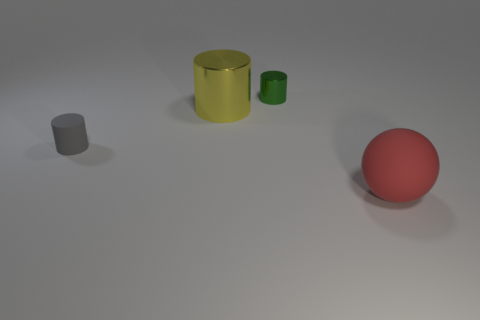What is the shape of the object that is behind the small rubber object and in front of the green cylinder?
Make the answer very short. Cylinder. The other small thing that is the same shape as the small gray thing is what color?
Provide a short and direct response. Green. Is there any other thing of the same color as the small metal thing?
Your answer should be compact. No. What is the shape of the rubber thing that is on the right side of the matte object that is on the left side of the thing that is in front of the tiny gray cylinder?
Keep it short and to the point. Sphere. There is a matte thing that is on the right side of the tiny rubber object; is its size the same as the shiny cylinder that is on the left side of the green cylinder?
Your answer should be very brief. Yes. How many red objects are made of the same material as the small green thing?
Offer a terse response. 0. There is a tiny object that is behind the small gray thing that is in front of the green shiny thing; how many things are on the right side of it?
Provide a succinct answer. 1. Do the large yellow thing and the gray rubber object have the same shape?
Keep it short and to the point. Yes. Are there any tiny objects of the same shape as the big shiny thing?
Give a very brief answer. Yes. What shape is the matte object that is the same size as the yellow metal object?
Provide a succinct answer. Sphere. 